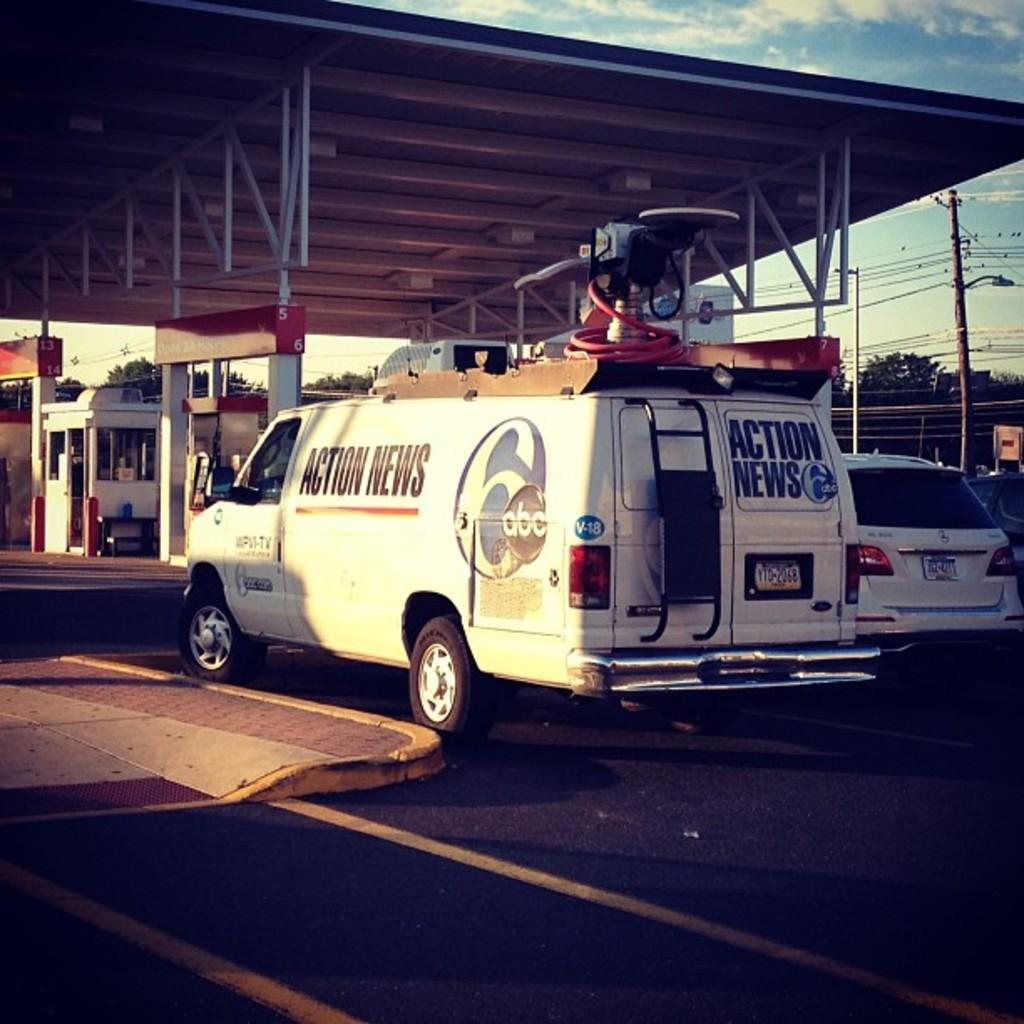<image>
Describe the image concisely. An Action News van from ABC is parked near a gas station. 